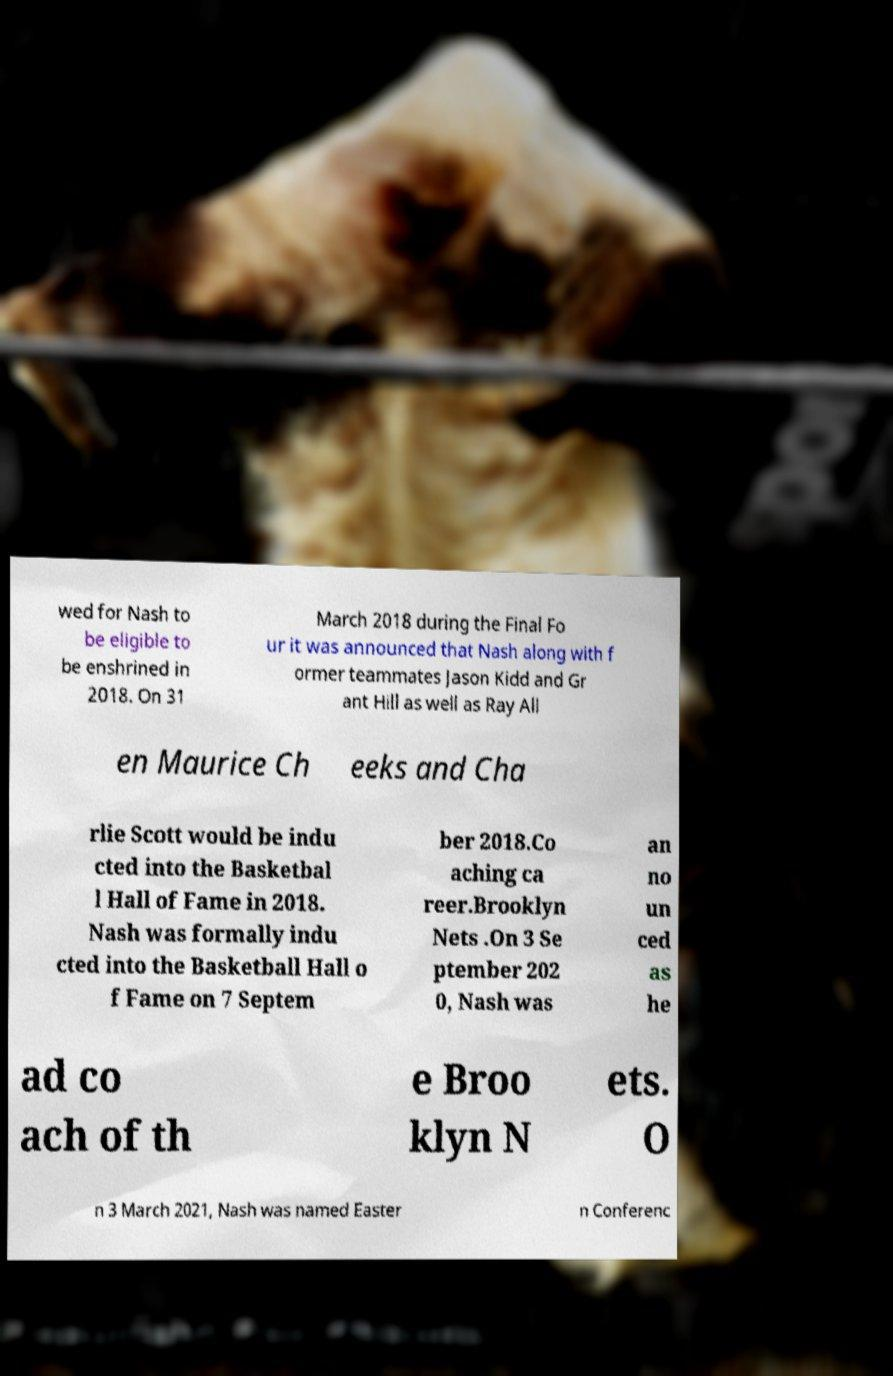There's text embedded in this image that I need extracted. Can you transcribe it verbatim? wed for Nash to be eligible to be enshrined in 2018. On 31 March 2018 during the Final Fo ur it was announced that Nash along with f ormer teammates Jason Kidd and Gr ant Hill as well as Ray All en Maurice Ch eeks and Cha rlie Scott would be indu cted into the Basketbal l Hall of Fame in 2018. Nash was formally indu cted into the Basketball Hall o f Fame on 7 Septem ber 2018.Co aching ca reer.Brooklyn Nets .On 3 Se ptember 202 0, Nash was an no un ced as he ad co ach of th e Broo klyn N ets. O n 3 March 2021, Nash was named Easter n Conferenc 